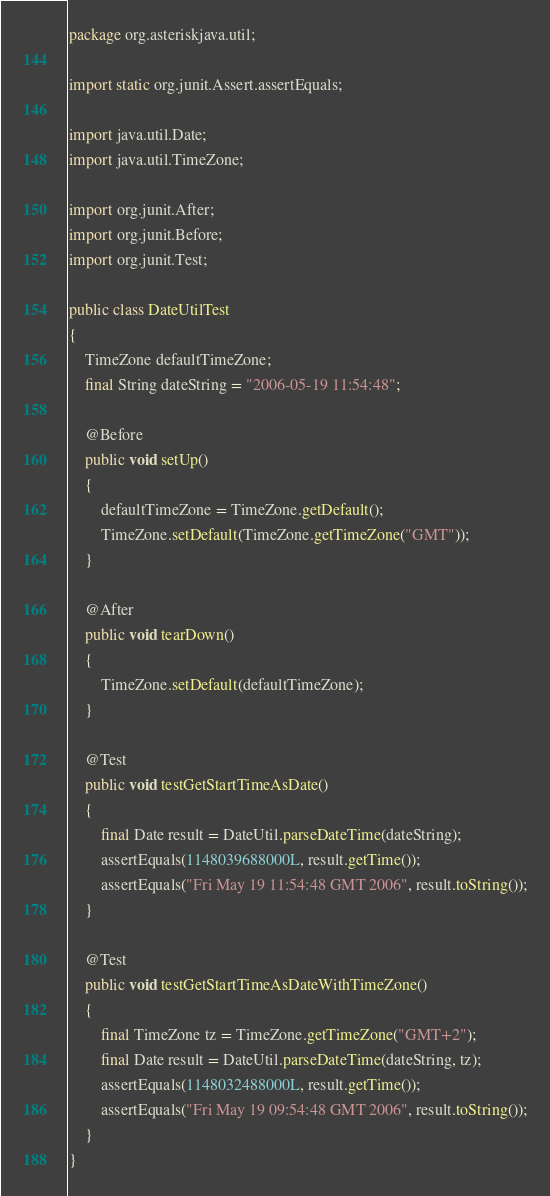<code> <loc_0><loc_0><loc_500><loc_500><_Java_>package org.asteriskjava.util;

import static org.junit.Assert.assertEquals;

import java.util.Date;
import java.util.TimeZone;

import org.junit.After;
import org.junit.Before;
import org.junit.Test;

public class DateUtilTest
{
    TimeZone defaultTimeZone;
    final String dateString = "2006-05-19 11:54:48";

    @Before
    public void setUp()
    {
        defaultTimeZone = TimeZone.getDefault();
        TimeZone.setDefault(TimeZone.getTimeZone("GMT"));
    }

    @After
    public void tearDown()
    {
        TimeZone.setDefault(defaultTimeZone);
    }

    @Test
    public void testGetStartTimeAsDate()
    {
        final Date result = DateUtil.parseDateTime(dateString);
        assertEquals(1148039688000L, result.getTime());
        assertEquals("Fri May 19 11:54:48 GMT 2006", result.toString());
    }

    @Test
    public void testGetStartTimeAsDateWithTimeZone()
    {
        final TimeZone tz = TimeZone.getTimeZone("GMT+2");
        final Date result = DateUtil.parseDateTime(dateString, tz);
        assertEquals(1148032488000L, result.getTime());
        assertEquals("Fri May 19 09:54:48 GMT 2006", result.toString());
    }
}
</code> 